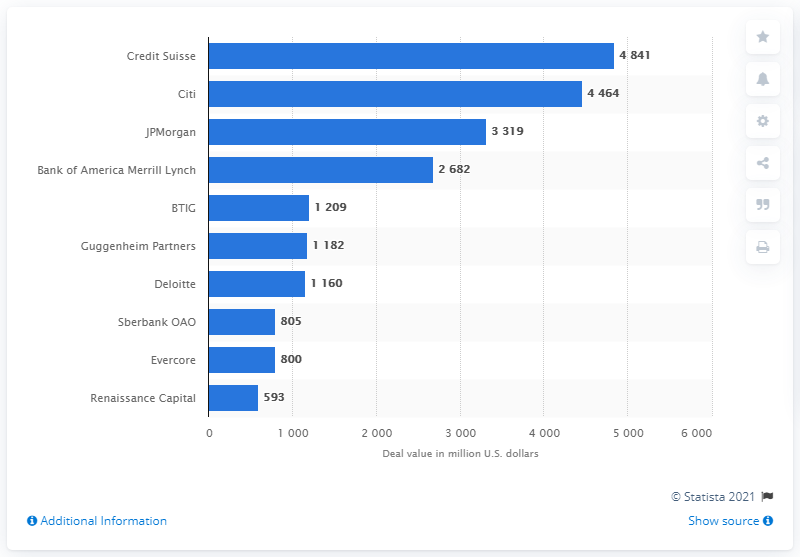List a handful of essential elements in this visual. In the first half of 2019, Credit Suisse was identified as the leading advisor to M&A deals in Russia. In US dollars, the deal value of Credit Suisse's deals was approximately 4,841. 